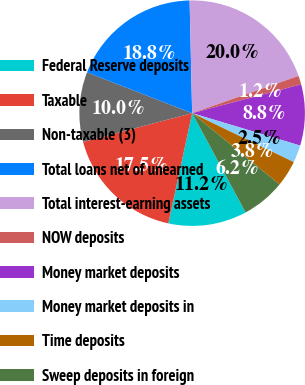Convert chart to OTSL. <chart><loc_0><loc_0><loc_500><loc_500><pie_chart><fcel>Federal Reserve deposits<fcel>Taxable<fcel>Non-taxable (3)<fcel>Total loans net of unearned<fcel>Total interest-earning assets<fcel>NOW deposits<fcel>Money market deposits<fcel>Money market deposits in<fcel>Time deposits<fcel>Sweep deposits in foreign<nl><fcel>11.25%<fcel>17.5%<fcel>10.0%<fcel>18.75%<fcel>20.0%<fcel>1.25%<fcel>8.75%<fcel>2.5%<fcel>3.75%<fcel>6.25%<nl></chart> 